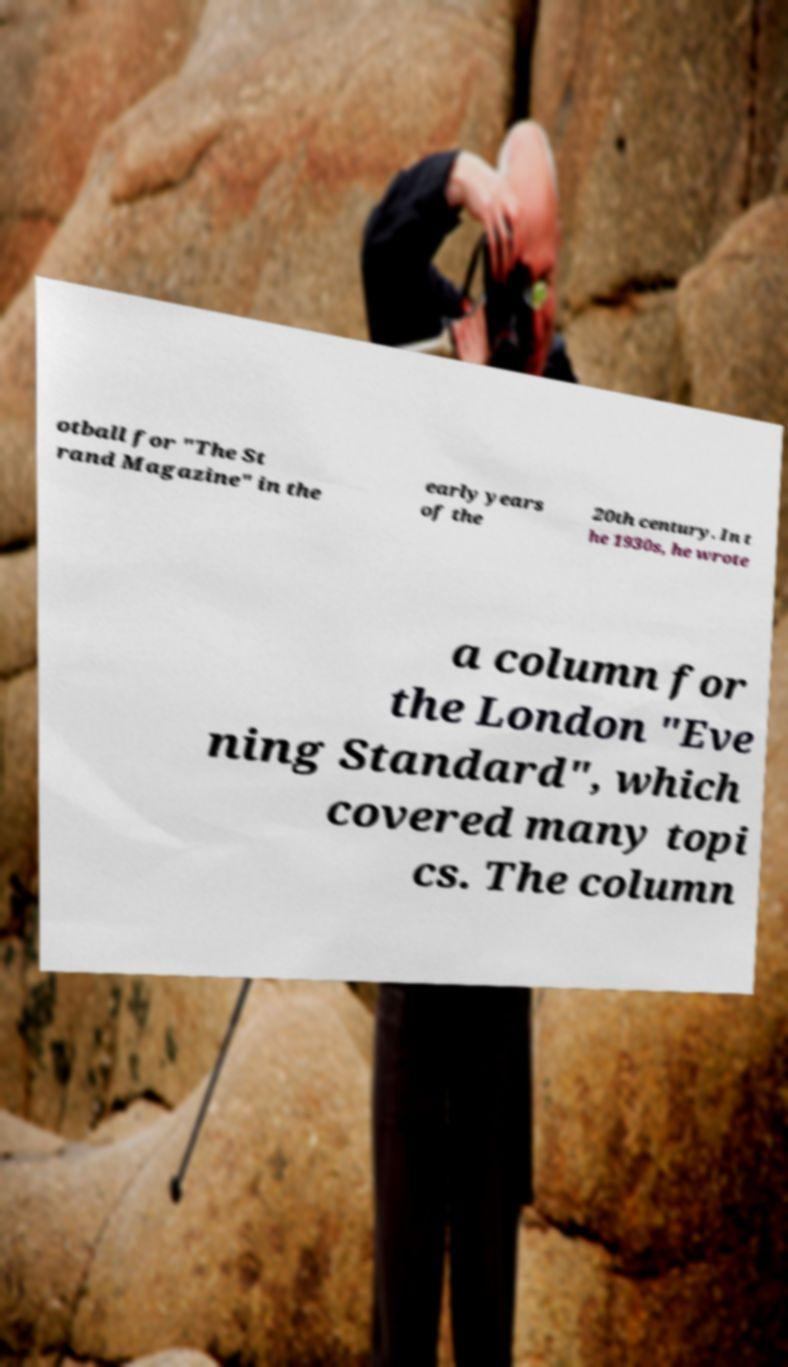Could you extract and type out the text from this image? otball for "The St rand Magazine" in the early years of the 20th century. In t he 1930s, he wrote a column for the London "Eve ning Standard", which covered many topi cs. The column 